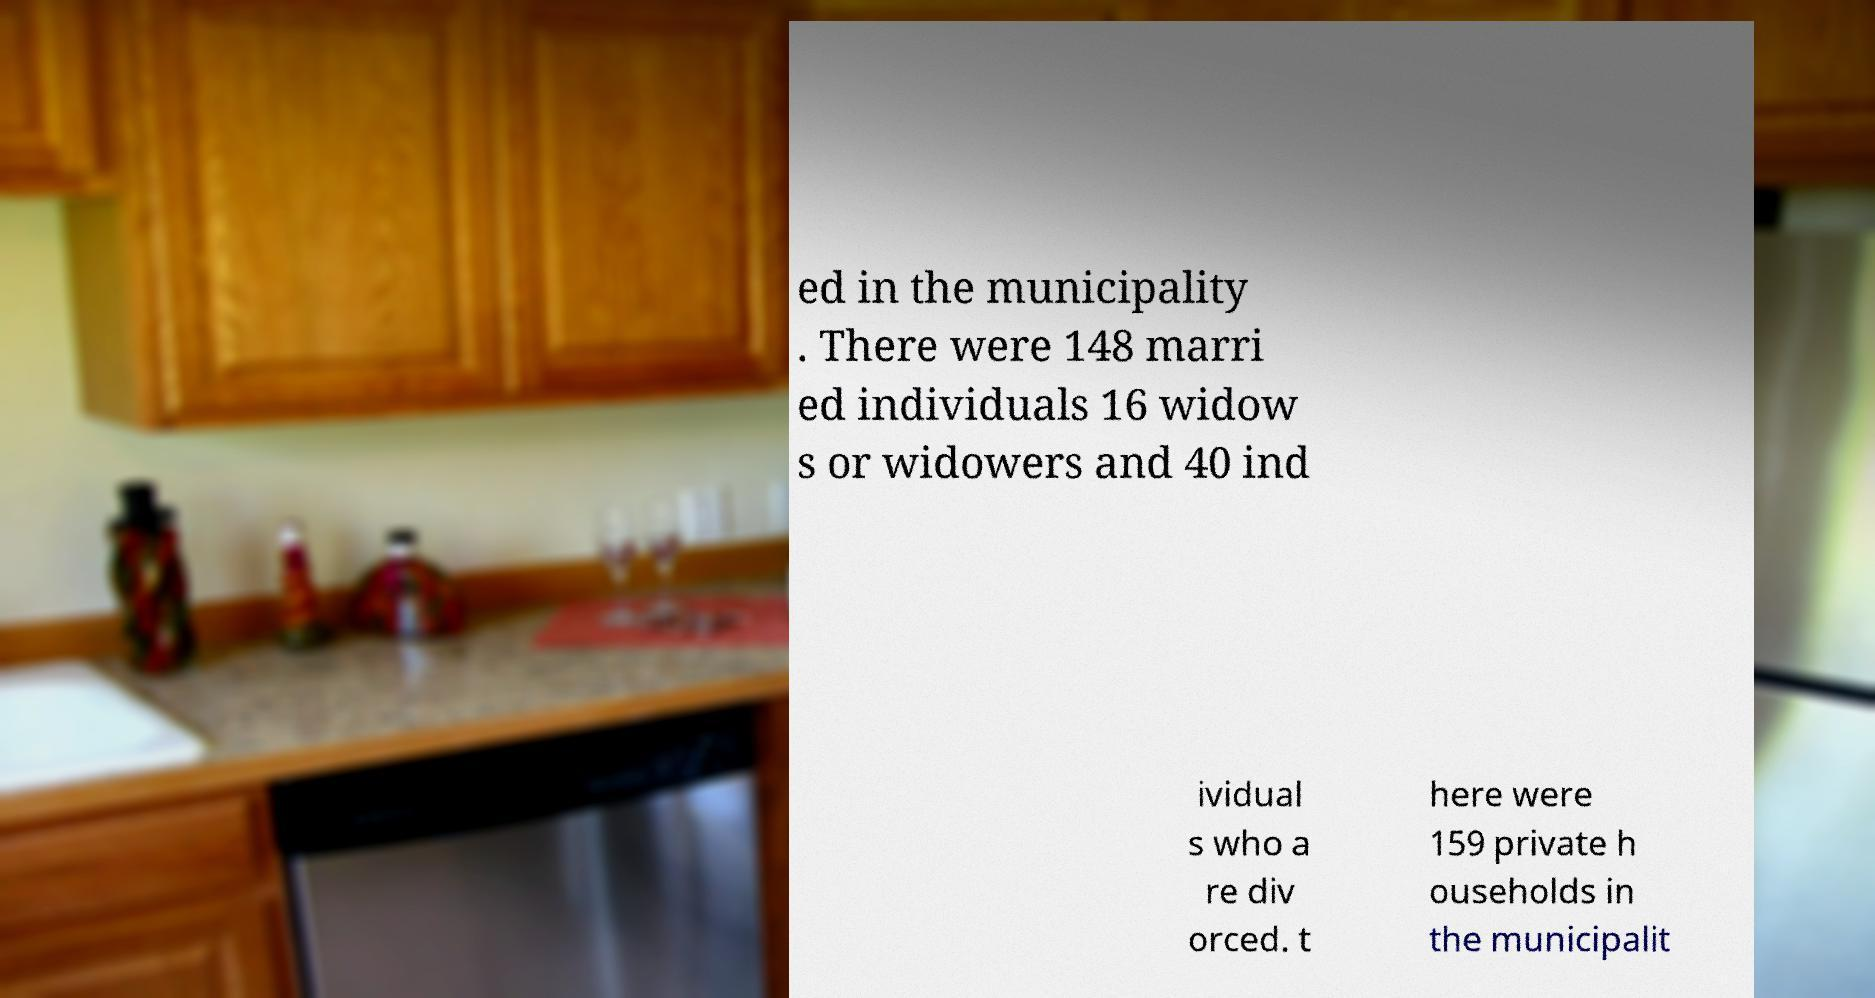Please read and relay the text visible in this image. What does it say? ed in the municipality . There were 148 marri ed individuals 16 widow s or widowers and 40 ind ividual s who a re div orced. t here were 159 private h ouseholds in the municipalit 